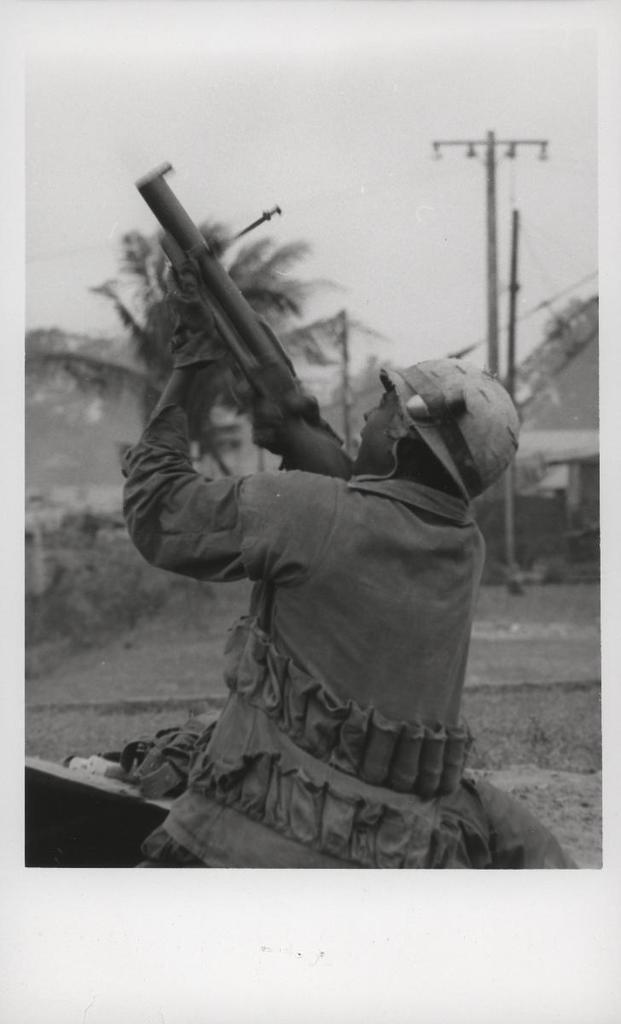Could you give a brief overview of what you see in this image? In this image I can see a person is holding gun and wearing helmet. Back I can see a house,current poles and trees. The image is in black and white. 